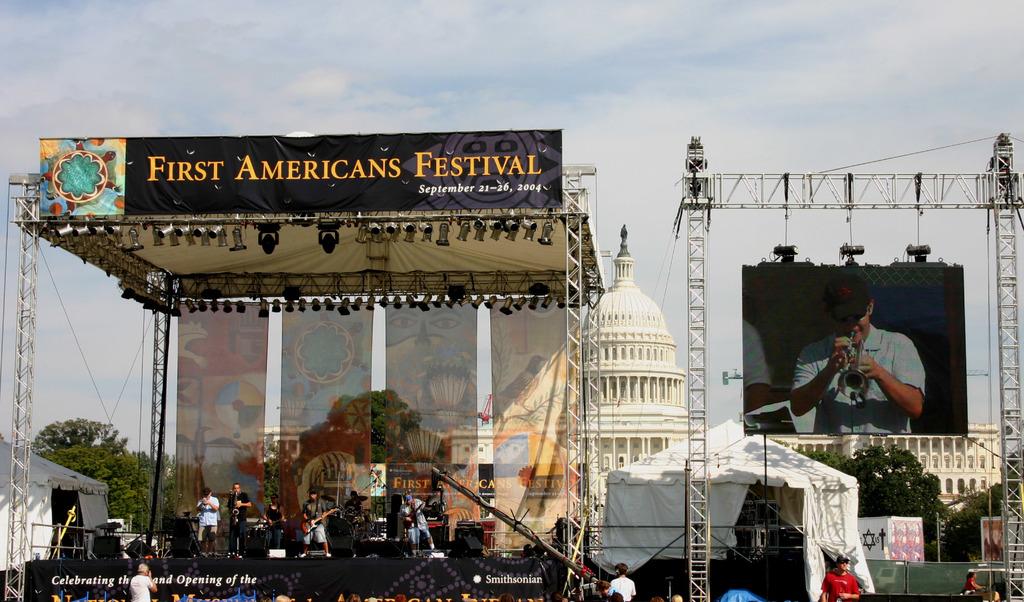What is the name of this festival?
Give a very brief answer. First americans festival. What is the date of this festival?
Make the answer very short. September 21-26, 2004. 